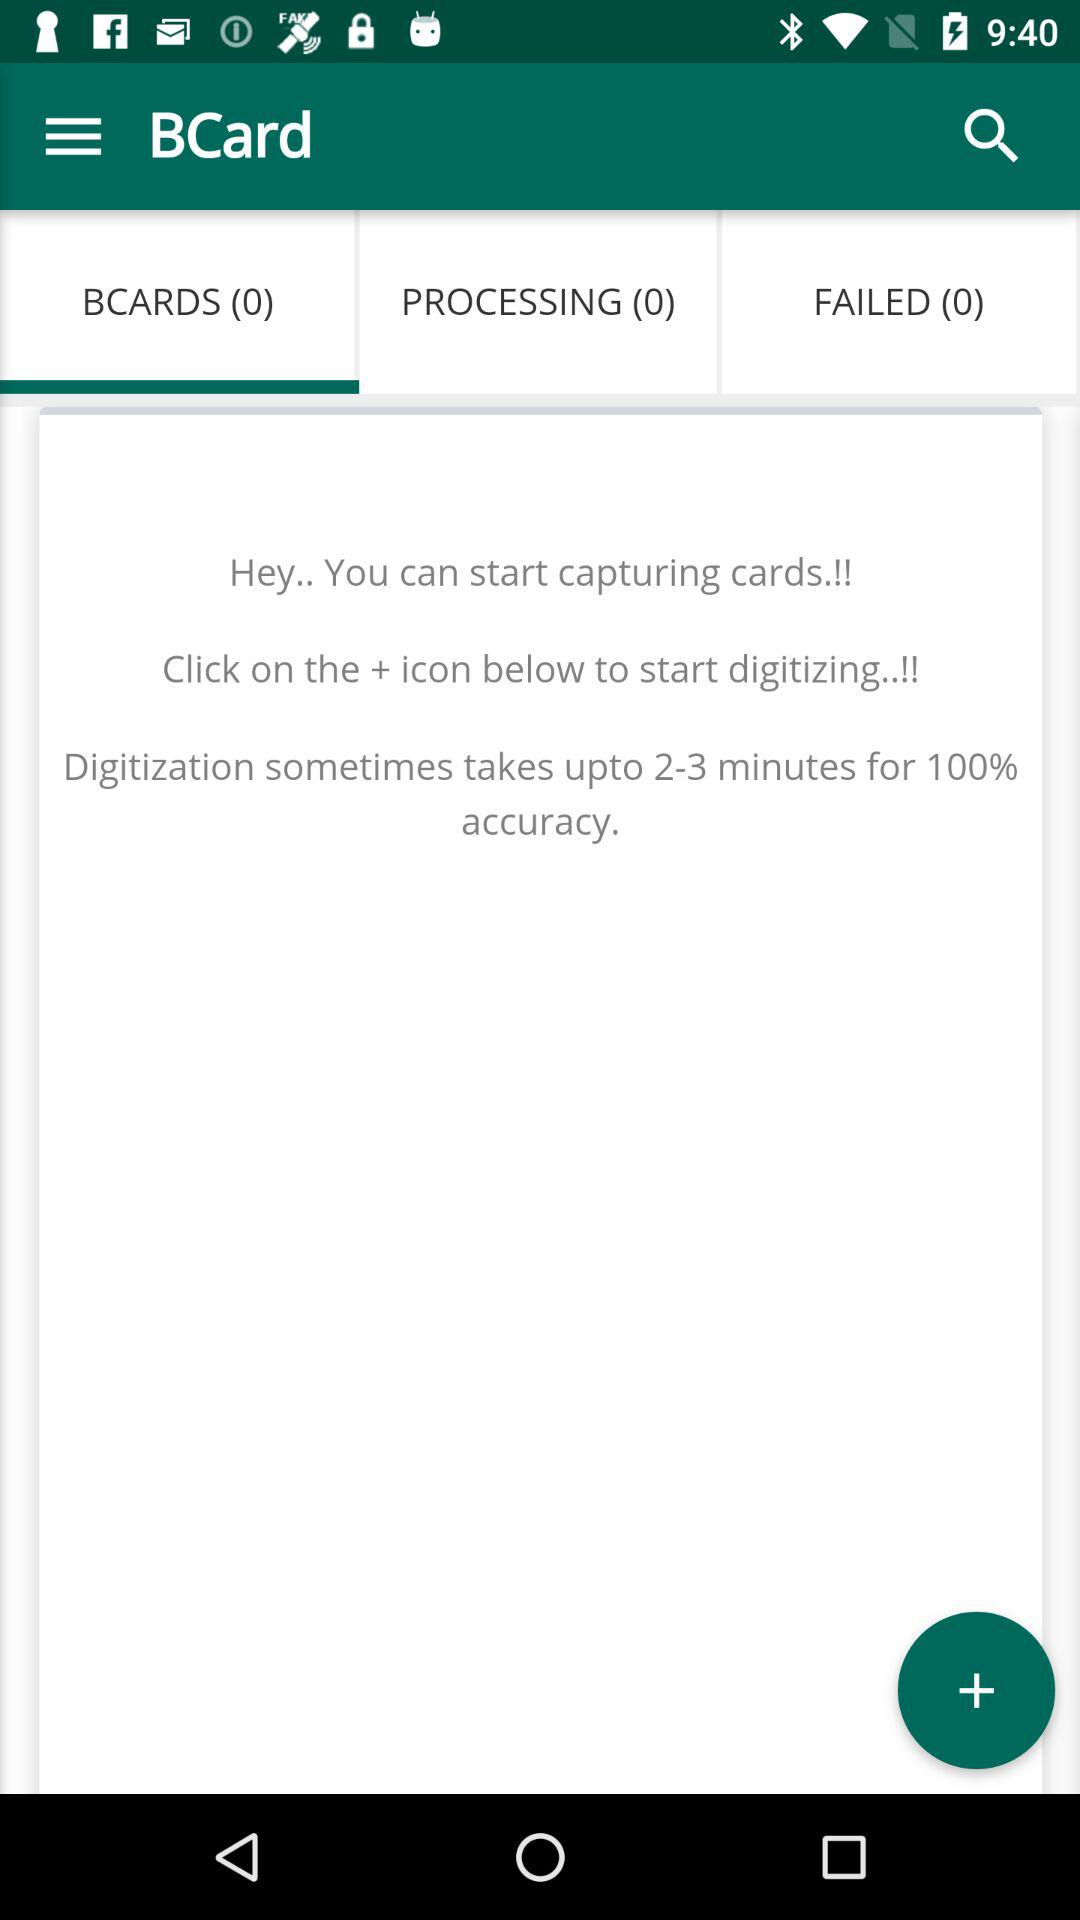What is the number mentioned beside "PROCESSING"? The number mentioned beside "PROCESSING" is 0. 